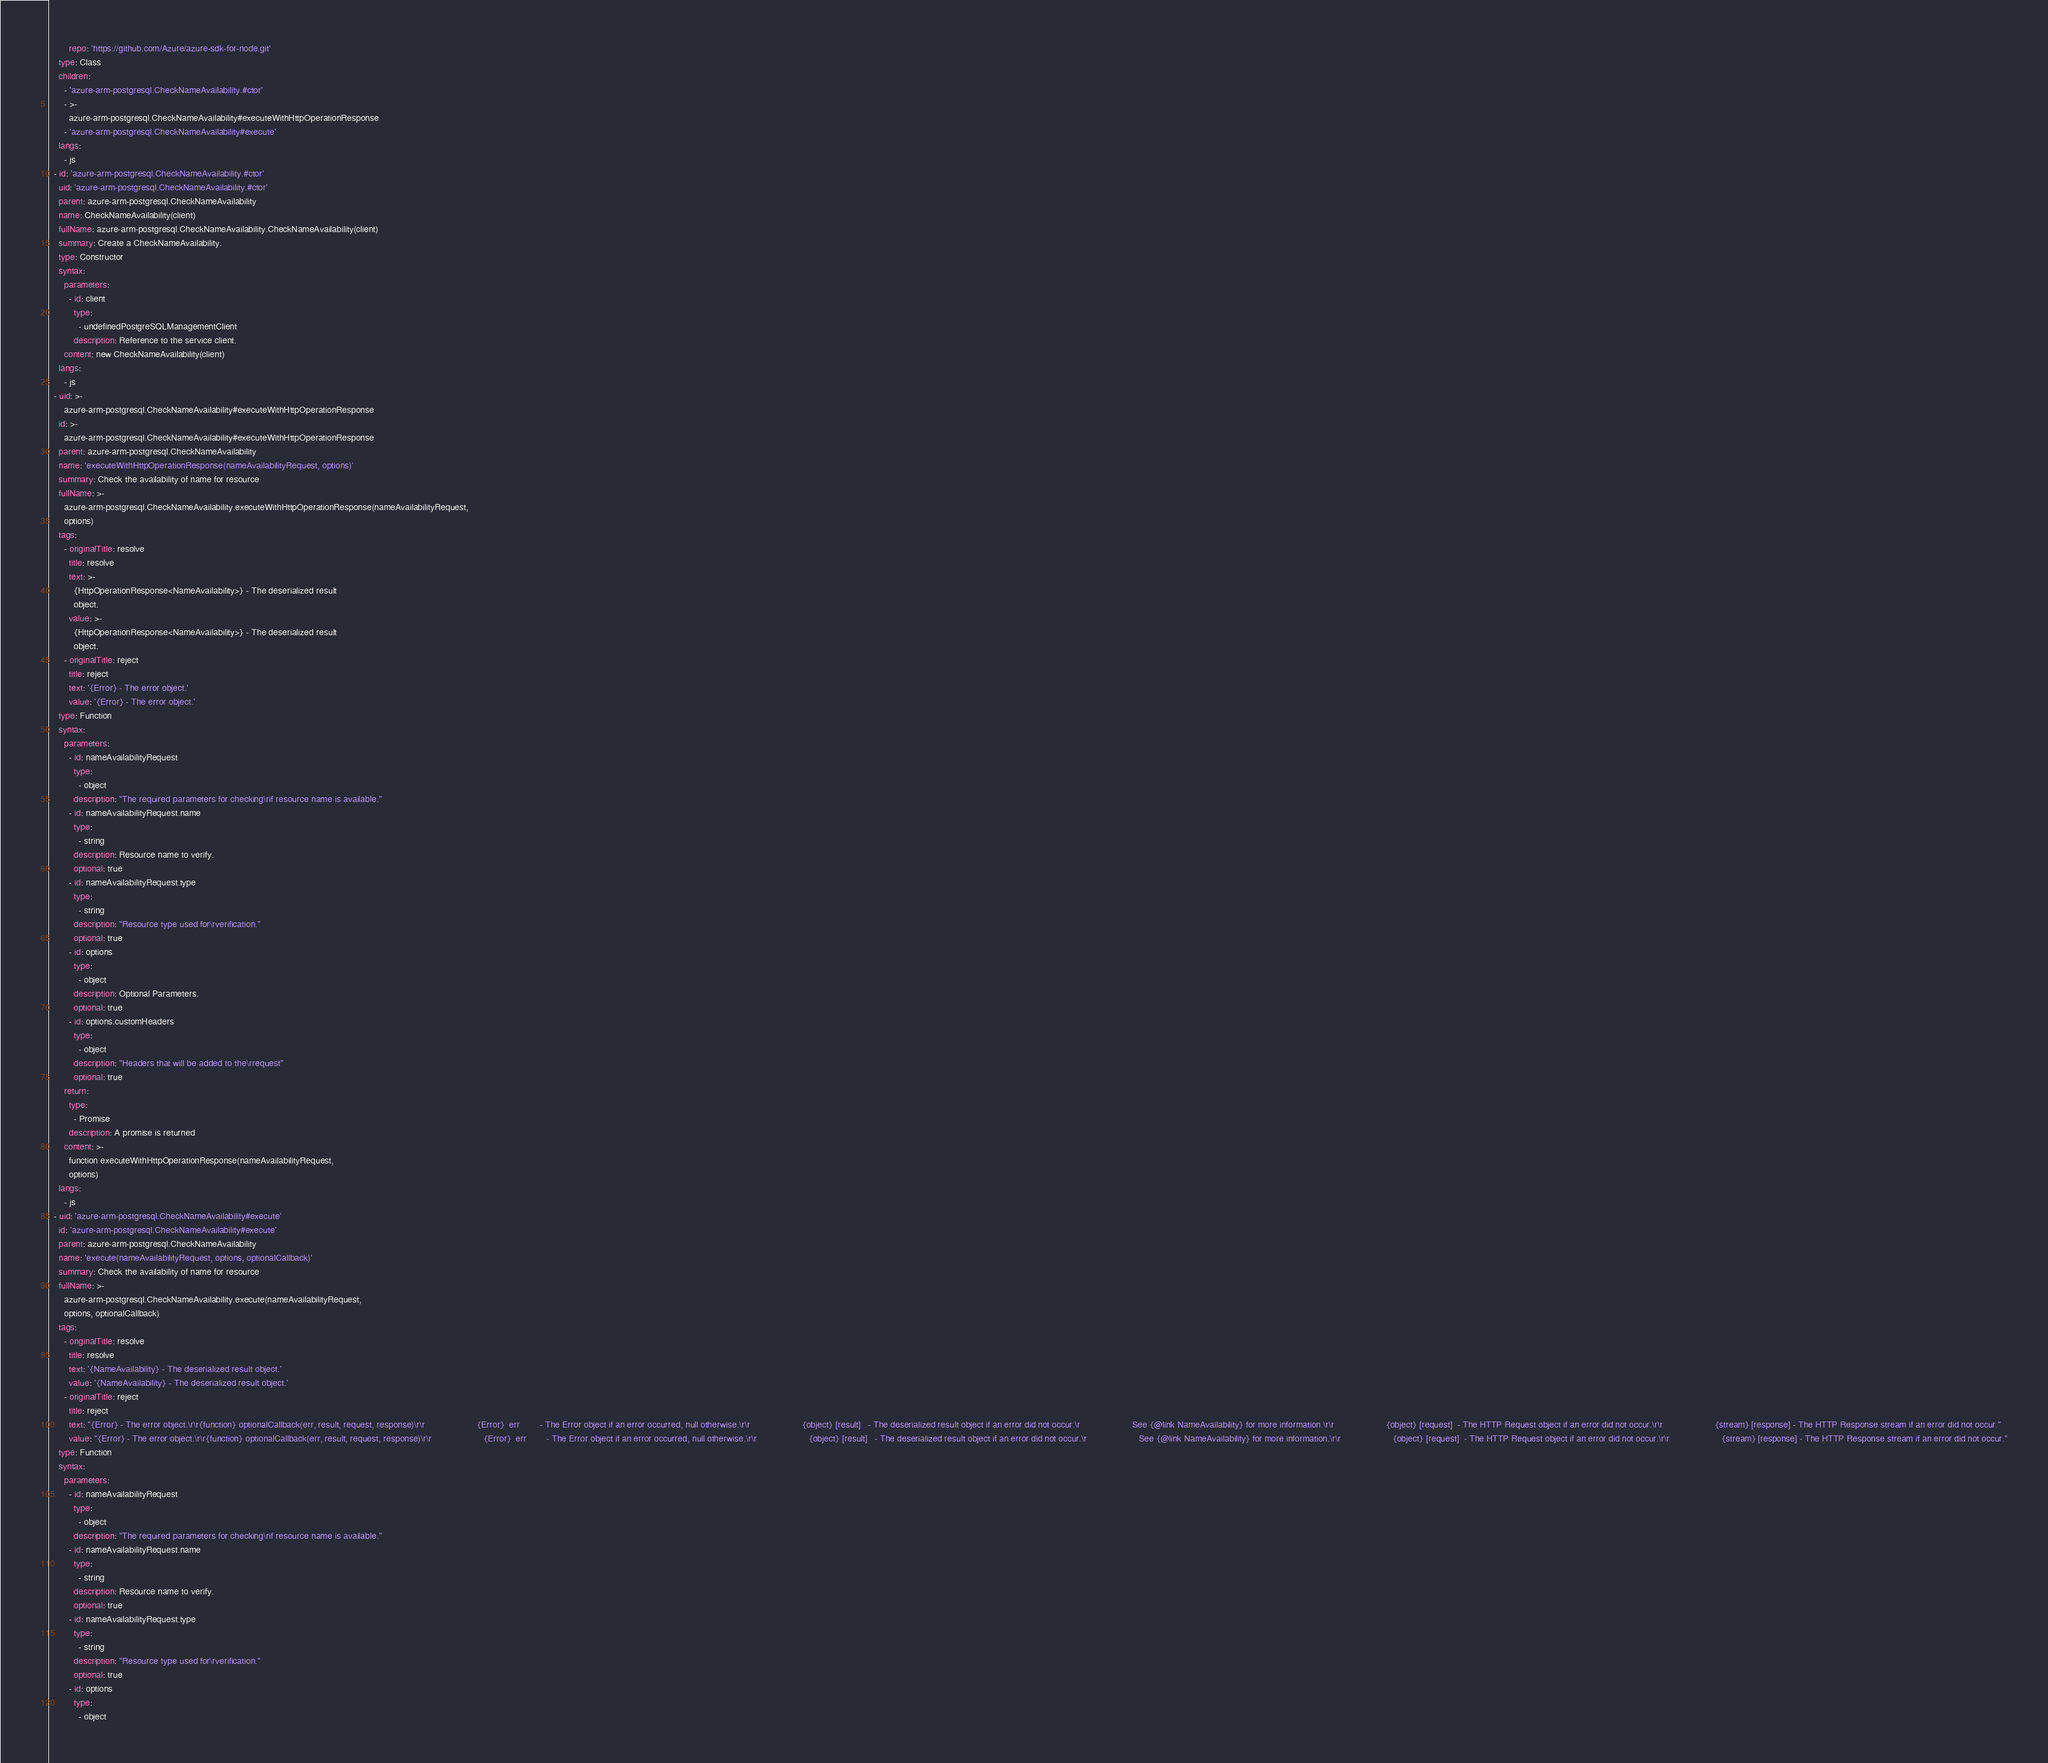<code> <loc_0><loc_0><loc_500><loc_500><_YAML_>        repo: 'https://github.com/Azure/azure-sdk-for-node.git'
    type: Class
    children:
      - 'azure-arm-postgresql.CheckNameAvailability.#ctor'
      - >-
        azure-arm-postgresql.CheckNameAvailability#executeWithHttpOperationResponse
      - 'azure-arm-postgresql.CheckNameAvailability#execute'
    langs:
      - js
  - id: 'azure-arm-postgresql.CheckNameAvailability.#ctor'
    uid: 'azure-arm-postgresql.CheckNameAvailability.#ctor'
    parent: azure-arm-postgresql.CheckNameAvailability
    name: CheckNameAvailability(client)
    fullName: azure-arm-postgresql.CheckNameAvailability.CheckNameAvailability(client)
    summary: Create a CheckNameAvailability.
    type: Constructor
    syntax:
      parameters:
        - id: client
          type:
            - undefinedPostgreSQLManagementClient
          description: Reference to the service client.
      content: new CheckNameAvailability(client)
    langs:
      - js
  - uid: >-
      azure-arm-postgresql.CheckNameAvailability#executeWithHttpOperationResponse
    id: >-
      azure-arm-postgresql.CheckNameAvailability#executeWithHttpOperationResponse
    parent: azure-arm-postgresql.CheckNameAvailability
    name: 'executeWithHttpOperationResponse(nameAvailabilityRequest, options)'
    summary: Check the availability of name for resource
    fullName: >-
      azure-arm-postgresql.CheckNameAvailability.executeWithHttpOperationResponse(nameAvailabilityRequest,
      options)
    tags:
      - originalTitle: resolve
        title: resolve
        text: >-
          {HttpOperationResponse<NameAvailability>} - The deserialized result
          object.
        value: >-
          {HttpOperationResponse<NameAvailability>} - The deserialized result
          object.
      - originalTitle: reject
        title: reject
        text: '{Error} - The error object.'
        value: '{Error} - The error object.'
    type: Function
    syntax:
      parameters:
        - id: nameAvailabilityRequest
          type:
            - object
          description: "The required parameters for checking\rif resource name is available."
        - id: nameAvailabilityRequest.name
          type:
            - string
          description: Resource name to verify.
          optional: true
        - id: nameAvailabilityRequest.type
          type:
            - string
          description: "Resource type used for\rverification."
          optional: true
        - id: options
          type:
            - object
          description: Optional Parameters.
          optional: true
        - id: options.customHeaders
          type:
            - object
          description: "Headers that will be added to the\rrequest"
          optional: true
      return:
        type:
          - Promise
        description: A promise is returned
      content: >-
        function executeWithHttpOperationResponse(nameAvailabilityRequest,
        options)
    langs:
      - js
  - uid: 'azure-arm-postgresql.CheckNameAvailability#execute'
    id: 'azure-arm-postgresql.CheckNameAvailability#execute'
    parent: azure-arm-postgresql.CheckNameAvailability
    name: 'execute(nameAvailabilityRequest, options, optionalCallback)'
    summary: Check the availability of name for resource
    fullName: >-
      azure-arm-postgresql.CheckNameAvailability.execute(nameAvailabilityRequest,
      options, optionalCallback)
    tags:
      - originalTitle: resolve
        title: resolve
        text: '{NameAvailability} - The deserialized result object.'
        value: '{NameAvailability} - The deserialized result object.'
      - originalTitle: reject
        title: reject
        text: "{Error} - The error object.\r\r{function} optionalCallback(err, result, request, response)\r\r                     {Error}  err        - The Error object if an error occurred, null otherwise.\r\r                     {object} [result]   - The deserialized result object if an error did not occur.\r                     See {@link NameAvailability} for more information.\r\r                     {object} [request]  - The HTTP Request object if an error did not occur.\r\r                     {stream} [response] - The HTTP Response stream if an error did not occur."
        value: "{Error} - The error object.\r\r{function} optionalCallback(err, result, request, response)\r\r                     {Error}  err        - The Error object if an error occurred, null otherwise.\r\r                     {object} [result]   - The deserialized result object if an error did not occur.\r                     See {@link NameAvailability} for more information.\r\r                     {object} [request]  - The HTTP Request object if an error did not occur.\r\r                     {stream} [response] - The HTTP Response stream if an error did not occur."
    type: Function
    syntax:
      parameters:
        - id: nameAvailabilityRequest
          type:
            - object
          description: "The required parameters for checking\rif resource name is available."
        - id: nameAvailabilityRequest.name
          type:
            - string
          description: Resource name to verify.
          optional: true
        - id: nameAvailabilityRequest.type
          type:
            - string
          description: "Resource type used for\rverification."
          optional: true
        - id: options
          type:
            - object</code> 